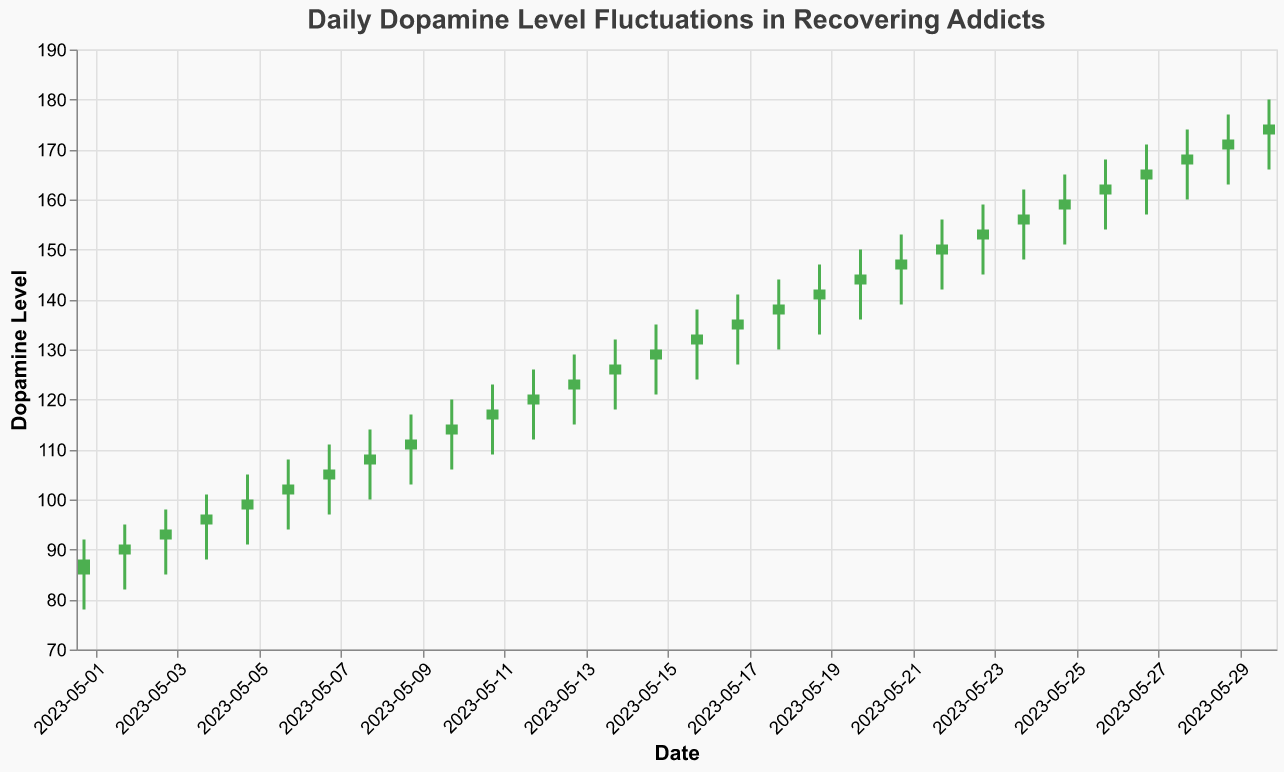What is the title of the chart? The title of the chart is the text at the top, which provides a summary of what the chart is about.
Answer: Daily Dopamine Level Fluctuations in Recovering Addicts How many days showed an increase in dopamine levels from the opening to the closing value? The number of days with higher closing values compared to opening values can be counted by counting green bars (upward movements).
Answer: 30 days On which day did dopamine levels fluctuate the most in terms of daily high and low difference? To determine the day with the most fluctuation, calculate the difference between the high and low values for each day and identify the maximum.
Answer: May 30th What was the closing dopamine level on May 15th? Locate the date "2023-05-15" and find the "Close" value associated with it.
Answer: 130 Which day had the highest closing dopamine level and what was the value? Look at all the "Close" values and find the maximum value and its corresponding date.
Answer: May 30th, 175 What was the average opening dopamine level for the first week? (May 1st to May 7th) Sum the opening values from May 1st to May 7th and divide by the number of days (7). Calculation: (85 + 89 + 92 + 95 + 98 + 101 + 104) / 7.
Answer: 94.86 Compare the dopamine levels between May 10th and May 20th. Did the levels generally increase or decrease? Examine the opening and closing levels from May 10th to May 20th and observe the general trend.
Answer: Increase What was the highest dopamine level recorded in the entire month? Find the highest "High" value among all the dates.
Answer: 180 (on May 30th) Which day had the smallest difference between the opening and closing dopamine levels? Calculate the absolute differences between opening and closing values for each day and identify the minimum.
Answer: May 11th How many times did the closing level equal the opening level? Identify the days where "Open" equals "Close".
Answer: 0 days 